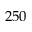<formula> <loc_0><loc_0><loc_500><loc_500>2 5 0</formula> 